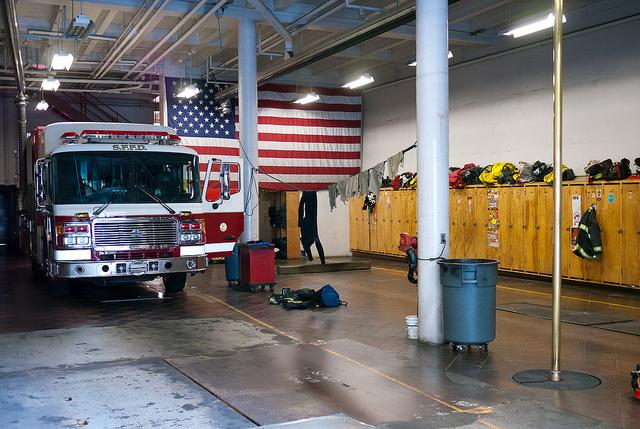What country's flag is displayed on the wall?
Be succinct. Usa. What type of truck is this?
Be succinct. Fire. Where is the flag?
Give a very brief answer. On wall. What kind of vehicle is this?
Be succinct. Fire truck. 